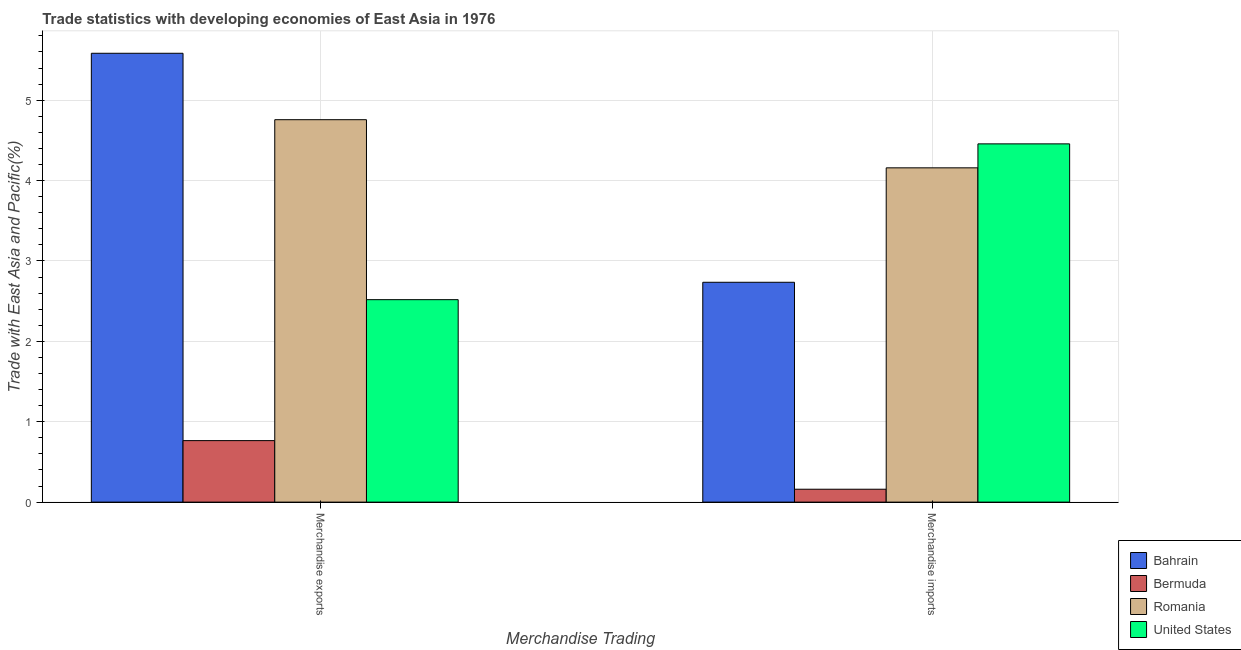How many different coloured bars are there?
Keep it short and to the point. 4. How many groups of bars are there?
Your answer should be compact. 2. Are the number of bars per tick equal to the number of legend labels?
Give a very brief answer. Yes. Are the number of bars on each tick of the X-axis equal?
Make the answer very short. Yes. How many bars are there on the 2nd tick from the left?
Your answer should be compact. 4. What is the label of the 1st group of bars from the left?
Provide a succinct answer. Merchandise exports. What is the merchandise imports in Bermuda?
Offer a terse response. 0.16. Across all countries, what is the maximum merchandise exports?
Your answer should be compact. 5.58. Across all countries, what is the minimum merchandise imports?
Keep it short and to the point. 0.16. In which country was the merchandise exports minimum?
Make the answer very short. Bermuda. What is the total merchandise exports in the graph?
Offer a terse response. 13.62. What is the difference between the merchandise imports in Bermuda and that in Romania?
Make the answer very short. -4. What is the difference between the merchandise exports in United States and the merchandise imports in Romania?
Provide a succinct answer. -1.64. What is the average merchandise imports per country?
Keep it short and to the point. 2.88. What is the difference between the merchandise imports and merchandise exports in United States?
Ensure brevity in your answer.  1.94. What is the ratio of the merchandise exports in Bahrain to that in Bermuda?
Your answer should be compact. 7.3. Is the merchandise exports in United States less than that in Bahrain?
Your response must be concise. Yes. What does the 1st bar from the left in Merchandise imports represents?
Make the answer very short. Bahrain. What does the 3rd bar from the right in Merchandise exports represents?
Make the answer very short. Bermuda. How many bars are there?
Give a very brief answer. 8. How many countries are there in the graph?
Your answer should be very brief. 4. What is the difference between two consecutive major ticks on the Y-axis?
Provide a succinct answer. 1. Are the values on the major ticks of Y-axis written in scientific E-notation?
Ensure brevity in your answer.  No. Does the graph contain any zero values?
Your answer should be compact. No. Does the graph contain grids?
Your answer should be very brief. Yes. Where does the legend appear in the graph?
Give a very brief answer. Bottom right. How are the legend labels stacked?
Keep it short and to the point. Vertical. What is the title of the graph?
Provide a succinct answer. Trade statistics with developing economies of East Asia in 1976. Does "Nigeria" appear as one of the legend labels in the graph?
Offer a very short reply. No. What is the label or title of the X-axis?
Keep it short and to the point. Merchandise Trading. What is the label or title of the Y-axis?
Your response must be concise. Trade with East Asia and Pacific(%). What is the Trade with East Asia and Pacific(%) in Bahrain in Merchandise exports?
Keep it short and to the point. 5.58. What is the Trade with East Asia and Pacific(%) of Bermuda in Merchandise exports?
Provide a succinct answer. 0.77. What is the Trade with East Asia and Pacific(%) of Romania in Merchandise exports?
Provide a short and direct response. 4.76. What is the Trade with East Asia and Pacific(%) in United States in Merchandise exports?
Give a very brief answer. 2.52. What is the Trade with East Asia and Pacific(%) of Bahrain in Merchandise imports?
Your response must be concise. 2.73. What is the Trade with East Asia and Pacific(%) of Bermuda in Merchandise imports?
Ensure brevity in your answer.  0.16. What is the Trade with East Asia and Pacific(%) in Romania in Merchandise imports?
Keep it short and to the point. 4.16. What is the Trade with East Asia and Pacific(%) of United States in Merchandise imports?
Your response must be concise. 4.46. Across all Merchandise Trading, what is the maximum Trade with East Asia and Pacific(%) of Bahrain?
Offer a terse response. 5.58. Across all Merchandise Trading, what is the maximum Trade with East Asia and Pacific(%) of Bermuda?
Keep it short and to the point. 0.77. Across all Merchandise Trading, what is the maximum Trade with East Asia and Pacific(%) in Romania?
Offer a very short reply. 4.76. Across all Merchandise Trading, what is the maximum Trade with East Asia and Pacific(%) in United States?
Provide a short and direct response. 4.46. Across all Merchandise Trading, what is the minimum Trade with East Asia and Pacific(%) of Bahrain?
Make the answer very short. 2.73. Across all Merchandise Trading, what is the minimum Trade with East Asia and Pacific(%) in Bermuda?
Make the answer very short. 0.16. Across all Merchandise Trading, what is the minimum Trade with East Asia and Pacific(%) of Romania?
Keep it short and to the point. 4.16. Across all Merchandise Trading, what is the minimum Trade with East Asia and Pacific(%) of United States?
Your answer should be compact. 2.52. What is the total Trade with East Asia and Pacific(%) of Bahrain in the graph?
Offer a terse response. 8.32. What is the total Trade with East Asia and Pacific(%) in Bermuda in the graph?
Offer a very short reply. 0.93. What is the total Trade with East Asia and Pacific(%) in Romania in the graph?
Provide a succinct answer. 8.92. What is the total Trade with East Asia and Pacific(%) in United States in the graph?
Your answer should be very brief. 6.98. What is the difference between the Trade with East Asia and Pacific(%) of Bahrain in Merchandise exports and that in Merchandise imports?
Your answer should be very brief. 2.85. What is the difference between the Trade with East Asia and Pacific(%) in Bermuda in Merchandise exports and that in Merchandise imports?
Keep it short and to the point. 0.6. What is the difference between the Trade with East Asia and Pacific(%) of Romania in Merchandise exports and that in Merchandise imports?
Provide a succinct answer. 0.6. What is the difference between the Trade with East Asia and Pacific(%) of United States in Merchandise exports and that in Merchandise imports?
Provide a short and direct response. -1.94. What is the difference between the Trade with East Asia and Pacific(%) of Bahrain in Merchandise exports and the Trade with East Asia and Pacific(%) of Bermuda in Merchandise imports?
Offer a very short reply. 5.42. What is the difference between the Trade with East Asia and Pacific(%) of Bahrain in Merchandise exports and the Trade with East Asia and Pacific(%) of Romania in Merchandise imports?
Your response must be concise. 1.43. What is the difference between the Trade with East Asia and Pacific(%) in Bahrain in Merchandise exports and the Trade with East Asia and Pacific(%) in United States in Merchandise imports?
Keep it short and to the point. 1.13. What is the difference between the Trade with East Asia and Pacific(%) of Bermuda in Merchandise exports and the Trade with East Asia and Pacific(%) of Romania in Merchandise imports?
Provide a succinct answer. -3.39. What is the difference between the Trade with East Asia and Pacific(%) in Bermuda in Merchandise exports and the Trade with East Asia and Pacific(%) in United States in Merchandise imports?
Offer a very short reply. -3.69. What is the difference between the Trade with East Asia and Pacific(%) of Romania in Merchandise exports and the Trade with East Asia and Pacific(%) of United States in Merchandise imports?
Ensure brevity in your answer.  0.3. What is the average Trade with East Asia and Pacific(%) in Bahrain per Merchandise Trading?
Offer a terse response. 4.16. What is the average Trade with East Asia and Pacific(%) of Bermuda per Merchandise Trading?
Provide a succinct answer. 0.46. What is the average Trade with East Asia and Pacific(%) in Romania per Merchandise Trading?
Provide a short and direct response. 4.46. What is the average Trade with East Asia and Pacific(%) of United States per Merchandise Trading?
Your response must be concise. 3.49. What is the difference between the Trade with East Asia and Pacific(%) of Bahrain and Trade with East Asia and Pacific(%) of Bermuda in Merchandise exports?
Give a very brief answer. 4.82. What is the difference between the Trade with East Asia and Pacific(%) in Bahrain and Trade with East Asia and Pacific(%) in Romania in Merchandise exports?
Your answer should be compact. 0.83. What is the difference between the Trade with East Asia and Pacific(%) in Bahrain and Trade with East Asia and Pacific(%) in United States in Merchandise exports?
Your answer should be compact. 3.07. What is the difference between the Trade with East Asia and Pacific(%) of Bermuda and Trade with East Asia and Pacific(%) of Romania in Merchandise exports?
Give a very brief answer. -3.99. What is the difference between the Trade with East Asia and Pacific(%) in Bermuda and Trade with East Asia and Pacific(%) in United States in Merchandise exports?
Offer a very short reply. -1.75. What is the difference between the Trade with East Asia and Pacific(%) of Romania and Trade with East Asia and Pacific(%) of United States in Merchandise exports?
Give a very brief answer. 2.24. What is the difference between the Trade with East Asia and Pacific(%) in Bahrain and Trade with East Asia and Pacific(%) in Bermuda in Merchandise imports?
Your answer should be very brief. 2.57. What is the difference between the Trade with East Asia and Pacific(%) of Bahrain and Trade with East Asia and Pacific(%) of Romania in Merchandise imports?
Provide a short and direct response. -1.42. What is the difference between the Trade with East Asia and Pacific(%) in Bahrain and Trade with East Asia and Pacific(%) in United States in Merchandise imports?
Keep it short and to the point. -1.72. What is the difference between the Trade with East Asia and Pacific(%) of Bermuda and Trade with East Asia and Pacific(%) of Romania in Merchandise imports?
Offer a terse response. -4. What is the difference between the Trade with East Asia and Pacific(%) in Bermuda and Trade with East Asia and Pacific(%) in United States in Merchandise imports?
Keep it short and to the point. -4.3. What is the difference between the Trade with East Asia and Pacific(%) of Romania and Trade with East Asia and Pacific(%) of United States in Merchandise imports?
Provide a succinct answer. -0.3. What is the ratio of the Trade with East Asia and Pacific(%) in Bahrain in Merchandise exports to that in Merchandise imports?
Offer a very short reply. 2.04. What is the ratio of the Trade with East Asia and Pacific(%) in Bermuda in Merchandise exports to that in Merchandise imports?
Your response must be concise. 4.77. What is the ratio of the Trade with East Asia and Pacific(%) of Romania in Merchandise exports to that in Merchandise imports?
Give a very brief answer. 1.14. What is the ratio of the Trade with East Asia and Pacific(%) in United States in Merchandise exports to that in Merchandise imports?
Your answer should be compact. 0.57. What is the difference between the highest and the second highest Trade with East Asia and Pacific(%) in Bahrain?
Give a very brief answer. 2.85. What is the difference between the highest and the second highest Trade with East Asia and Pacific(%) in Bermuda?
Your answer should be compact. 0.6. What is the difference between the highest and the second highest Trade with East Asia and Pacific(%) in Romania?
Your answer should be compact. 0.6. What is the difference between the highest and the second highest Trade with East Asia and Pacific(%) in United States?
Ensure brevity in your answer.  1.94. What is the difference between the highest and the lowest Trade with East Asia and Pacific(%) in Bahrain?
Your answer should be very brief. 2.85. What is the difference between the highest and the lowest Trade with East Asia and Pacific(%) of Bermuda?
Your answer should be very brief. 0.6. What is the difference between the highest and the lowest Trade with East Asia and Pacific(%) of Romania?
Ensure brevity in your answer.  0.6. What is the difference between the highest and the lowest Trade with East Asia and Pacific(%) of United States?
Give a very brief answer. 1.94. 